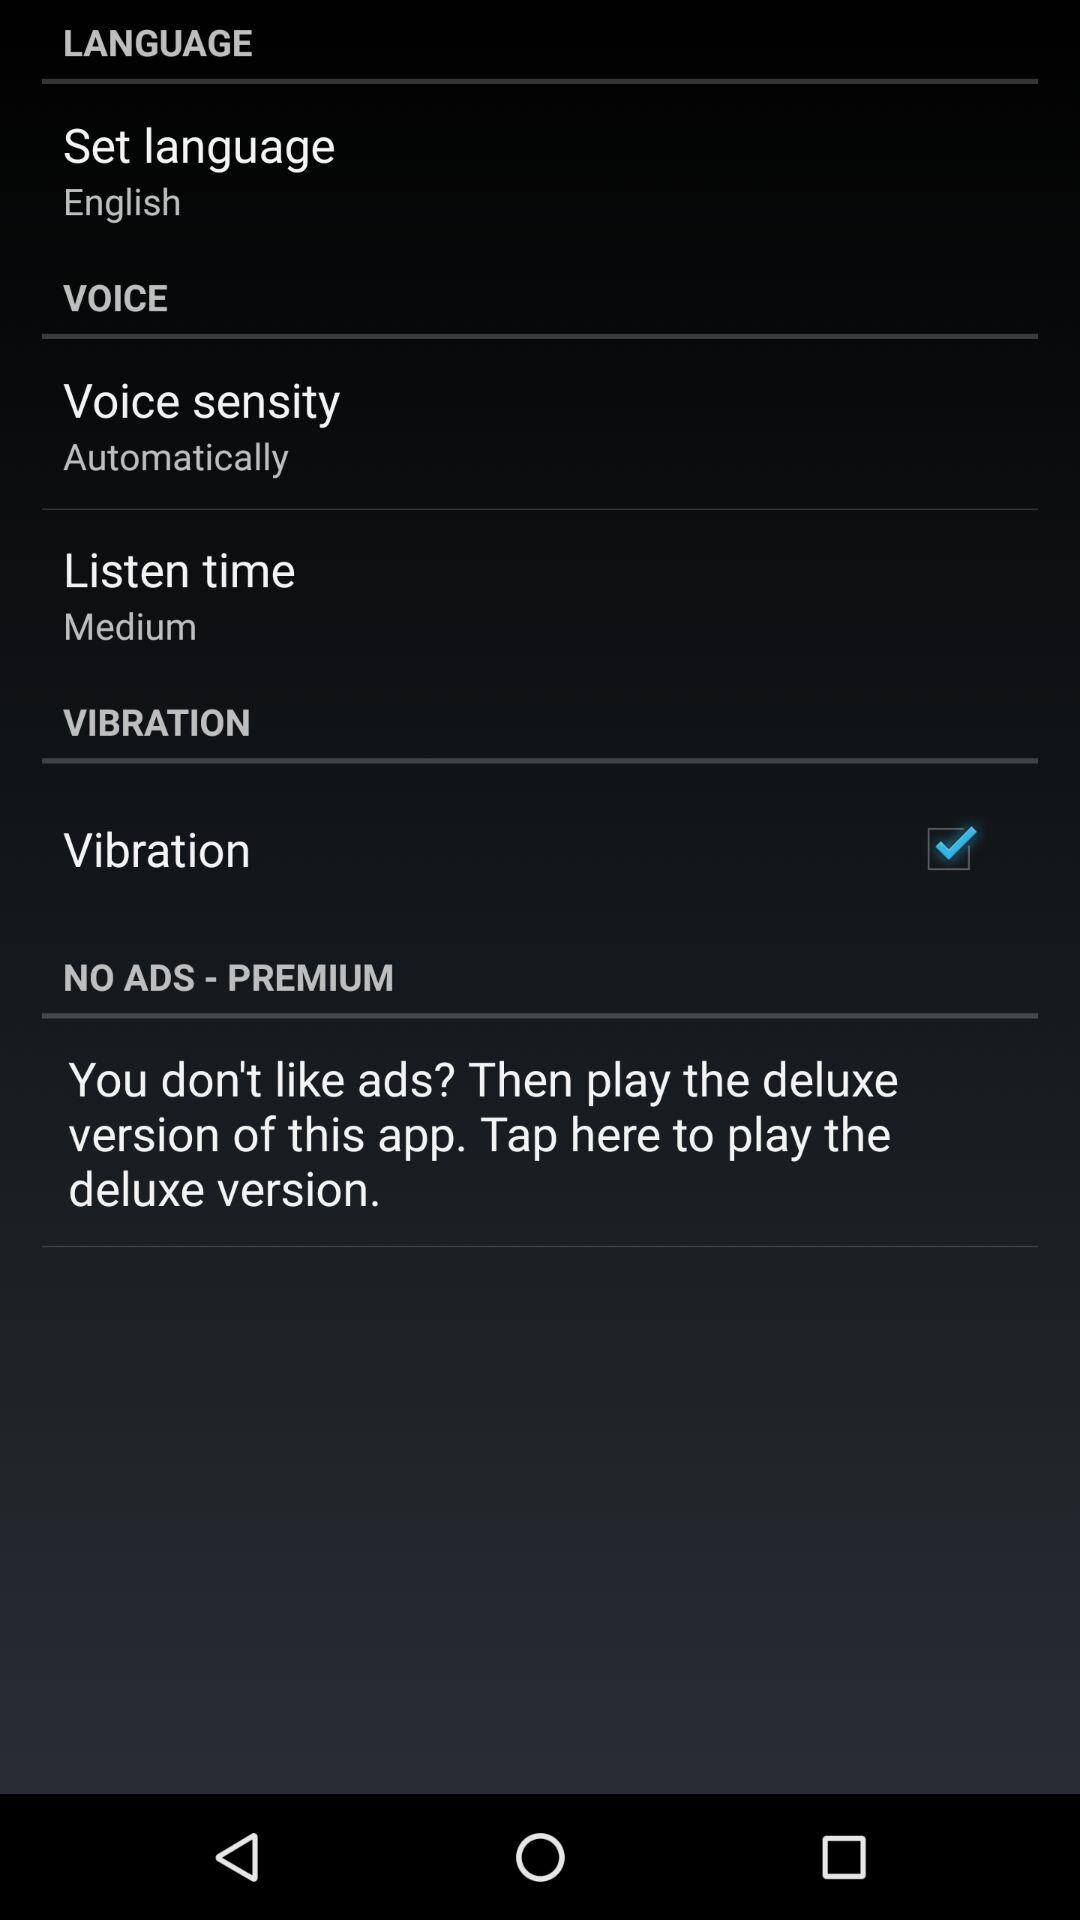Is "VOICE" checked or unchecked?
When the provided information is insufficient, respond with <no answer>. <no answer> 